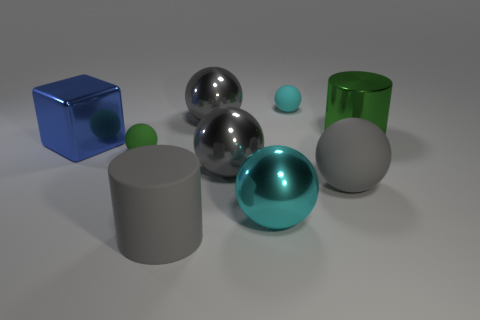How many gray balls must be subtracted to get 1 gray balls? 2 Subtract all yellow cylinders. How many gray spheres are left? 3 Subtract all small cyan matte spheres. How many spheres are left? 5 Subtract all green balls. How many balls are left? 5 Subtract 1 balls. How many balls are left? 5 Subtract all purple balls. Subtract all gray blocks. How many balls are left? 6 Add 1 large green metal cylinders. How many objects exist? 10 Subtract all spheres. How many objects are left? 3 Add 1 tiny spheres. How many tiny spheres are left? 3 Add 4 big cyan shiny spheres. How many big cyan shiny spheres exist? 5 